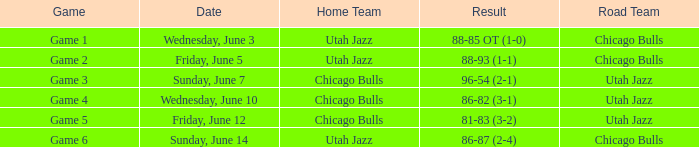What transpired in game of game 5? 81-83 (3-2). 